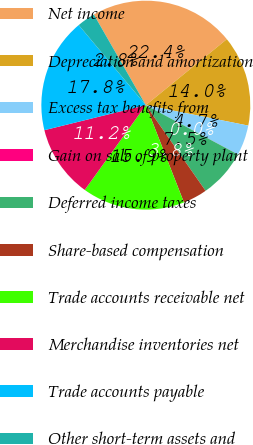Convert chart. <chart><loc_0><loc_0><loc_500><loc_500><pie_chart><fcel>Net income<fcel>Depreciation and amortization<fcel>Excess tax benefits from<fcel>Gain on sale of property plant<fcel>Deferred income taxes<fcel>Share-based compensation<fcel>Trade accounts receivable net<fcel>Merchandise inventories net<fcel>Trade accounts payable<fcel>Other short-term assets and<nl><fcel>22.41%<fcel>14.01%<fcel>4.68%<fcel>0.01%<fcel>7.48%<fcel>3.75%<fcel>15.88%<fcel>11.21%<fcel>17.75%<fcel>2.81%<nl></chart> 